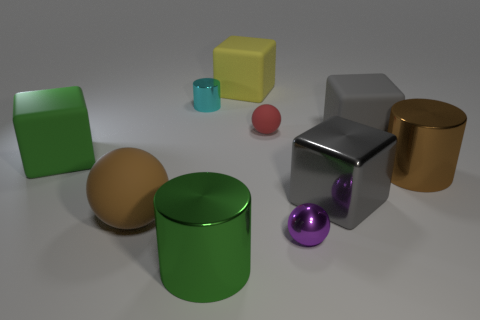Subtract all cylinders. How many objects are left? 7 Subtract all tiny green objects. Subtract all big green objects. How many objects are left? 8 Add 6 small red rubber spheres. How many small red rubber spheres are left? 7 Add 5 purple cylinders. How many purple cylinders exist? 5 Subtract 0 yellow balls. How many objects are left? 10 